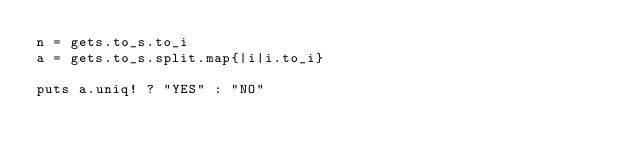Convert code to text. <code><loc_0><loc_0><loc_500><loc_500><_Ruby_>n = gets.to_s.to_i
a = gets.to_s.split.map{|i|i.to_i}

puts a.uniq! ? "YES" : "NO"</code> 